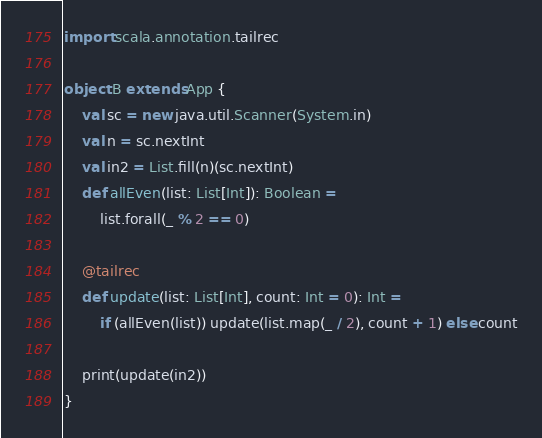<code> <loc_0><loc_0><loc_500><loc_500><_Scala_>import scala.annotation.tailrec

object B extends App {
    val sc = new java.util.Scanner(System.in)
    val n = sc.nextInt
    val in2 = List.fill(n)(sc.nextInt)
    def allEven(list: List[Int]): Boolean =
        list.forall(_ % 2 == 0)
    
    @tailrec
    def update(list: List[Int], count: Int = 0): Int =
        if (allEven(list)) update(list.map(_ / 2), count + 1) else count
    
    print(update(in2))
}</code> 